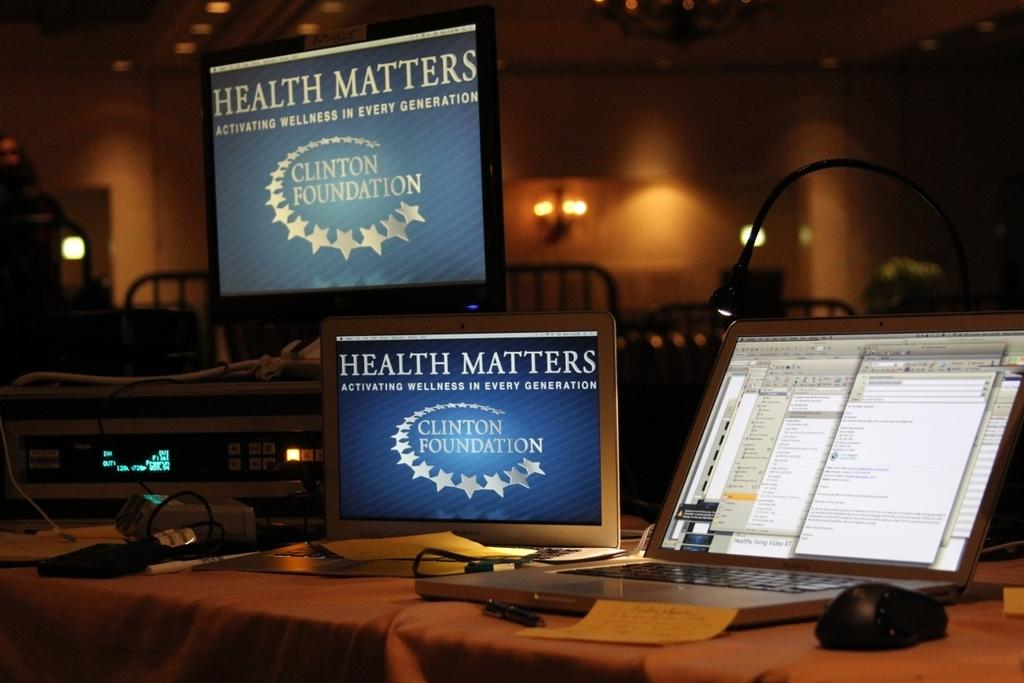Provide a one-sentence caption for the provided image. Health matters is displayed on monitors next to a laptop. 